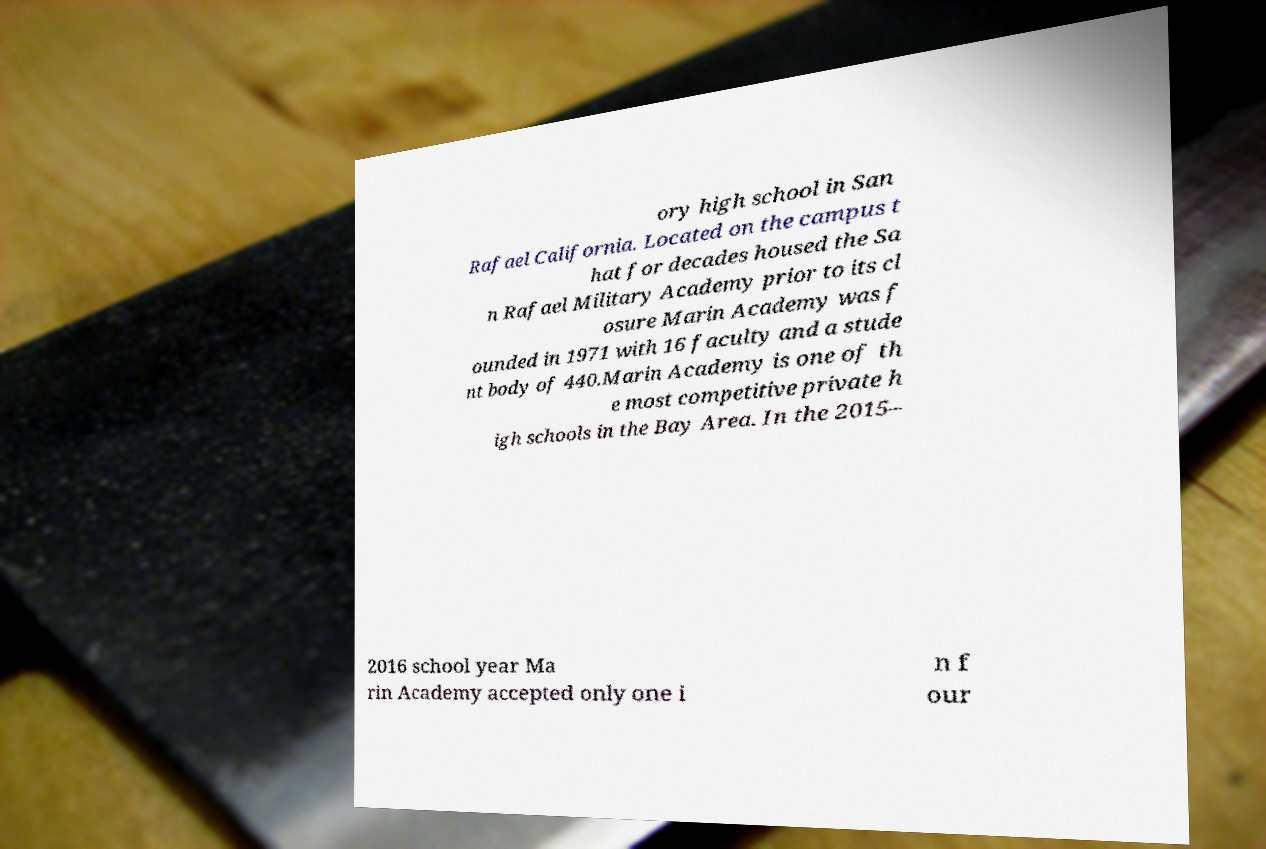Can you read and provide the text displayed in the image?This photo seems to have some interesting text. Can you extract and type it out for me? ory high school in San Rafael California. Located on the campus t hat for decades housed the Sa n Rafael Military Academy prior to its cl osure Marin Academy was f ounded in 1971 with 16 faculty and a stude nt body of 440.Marin Academy is one of th e most competitive private h igh schools in the Bay Area. In the 2015– 2016 school year Ma rin Academy accepted only one i n f our 